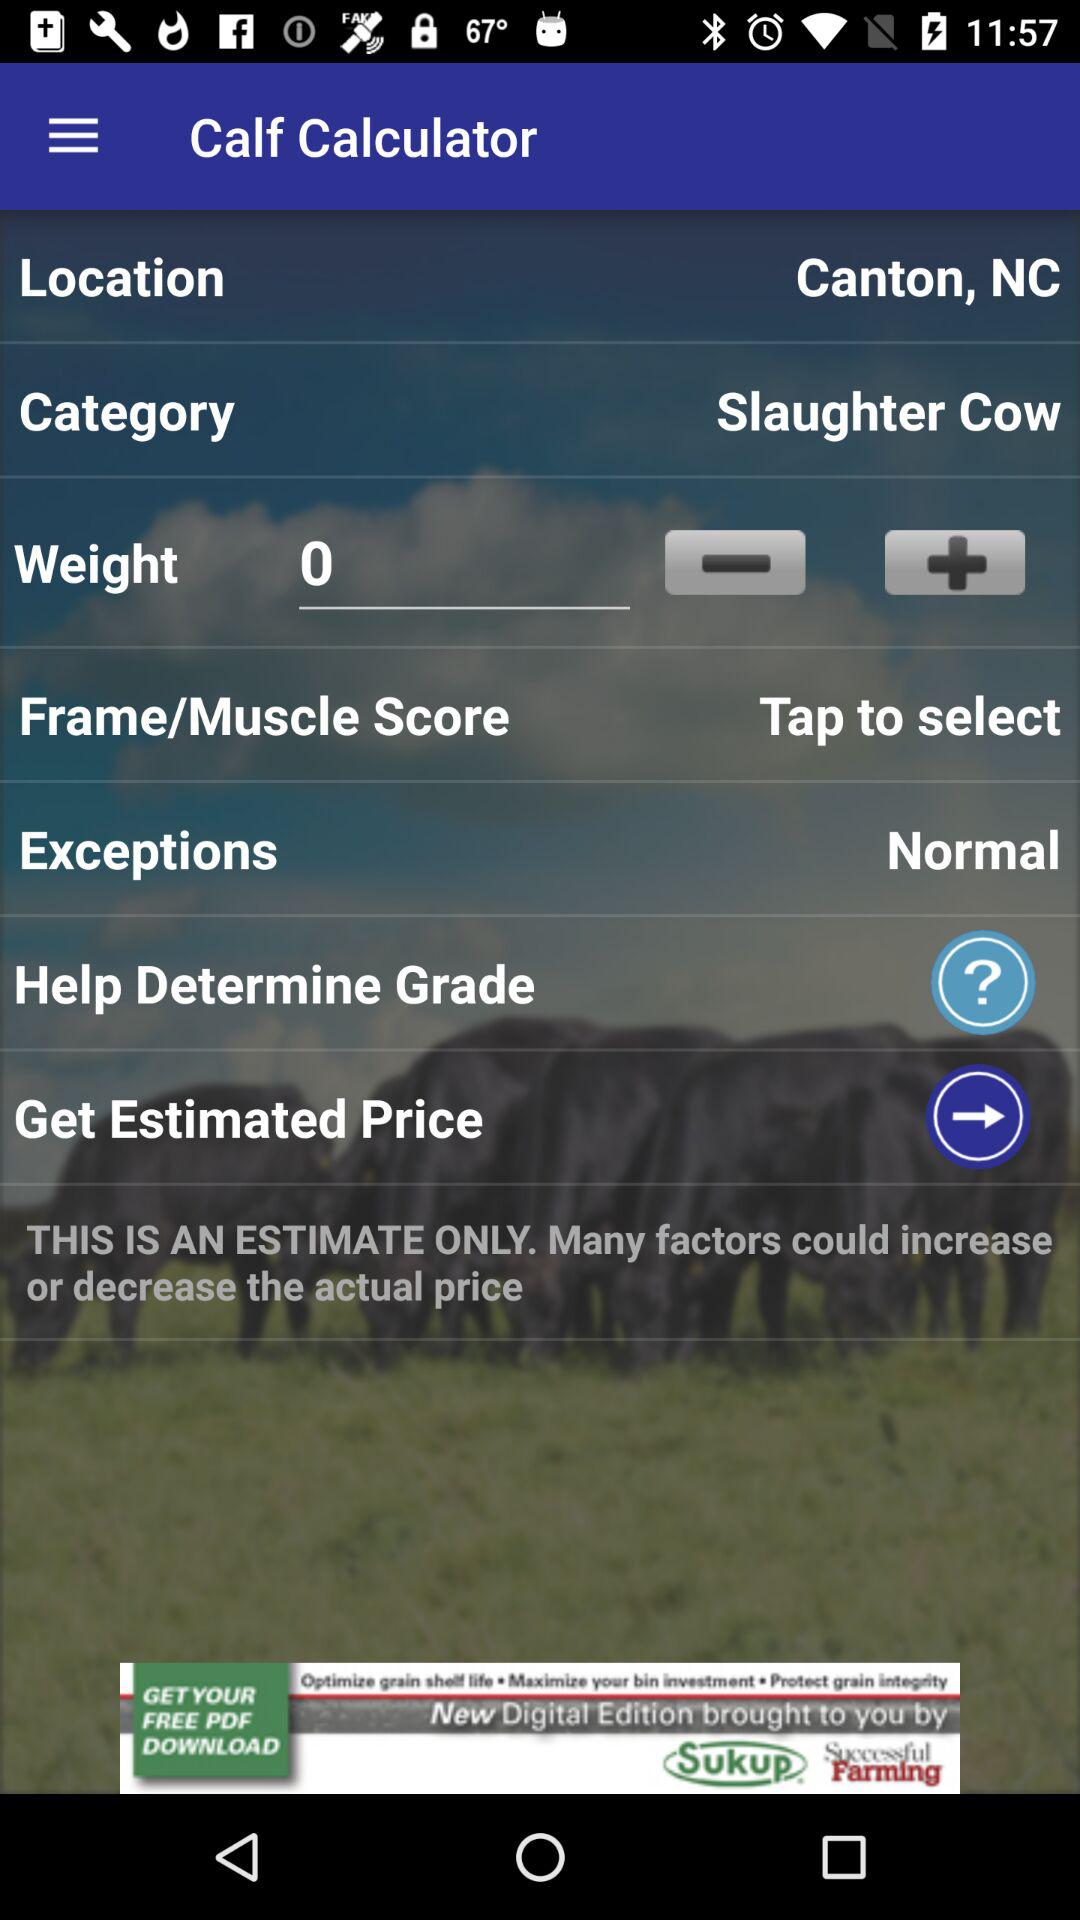What is the location? The location is Canton, NC. 